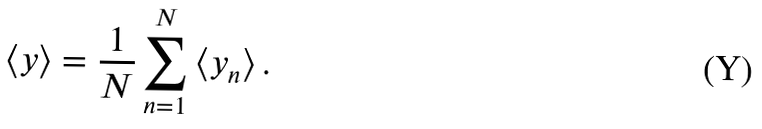Convert formula to latex. <formula><loc_0><loc_0><loc_500><loc_500>\left < y \right > = \frac { 1 } { N } \sum _ { n = 1 } ^ { N } \left < y _ { n } \right > .</formula> 